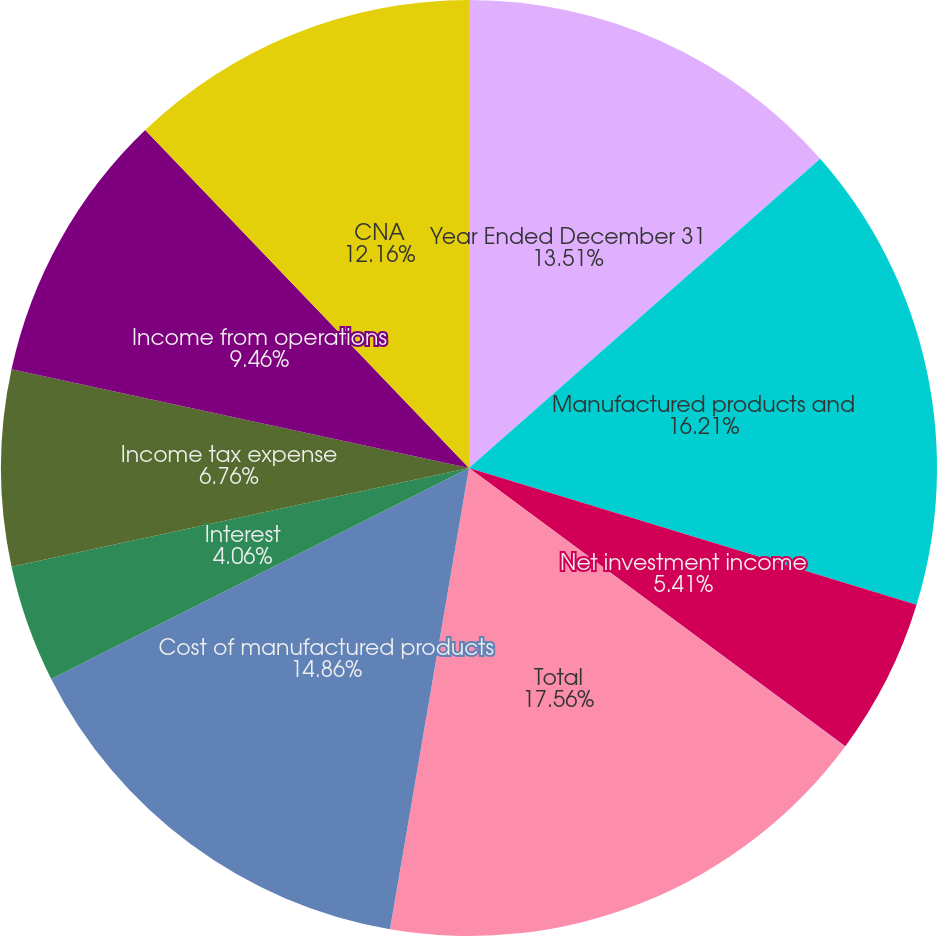Convert chart. <chart><loc_0><loc_0><loc_500><loc_500><pie_chart><fcel>Year Ended December 31<fcel>Manufactured products and<fcel>Net investment income<fcel>Investment losses<fcel>Total<fcel>Cost of manufactured products<fcel>Interest<fcel>Income tax expense<fcel>Income from operations<fcel>CNA<nl><fcel>13.51%<fcel>16.21%<fcel>5.41%<fcel>0.01%<fcel>17.56%<fcel>14.86%<fcel>4.06%<fcel>6.76%<fcel>9.46%<fcel>12.16%<nl></chart> 